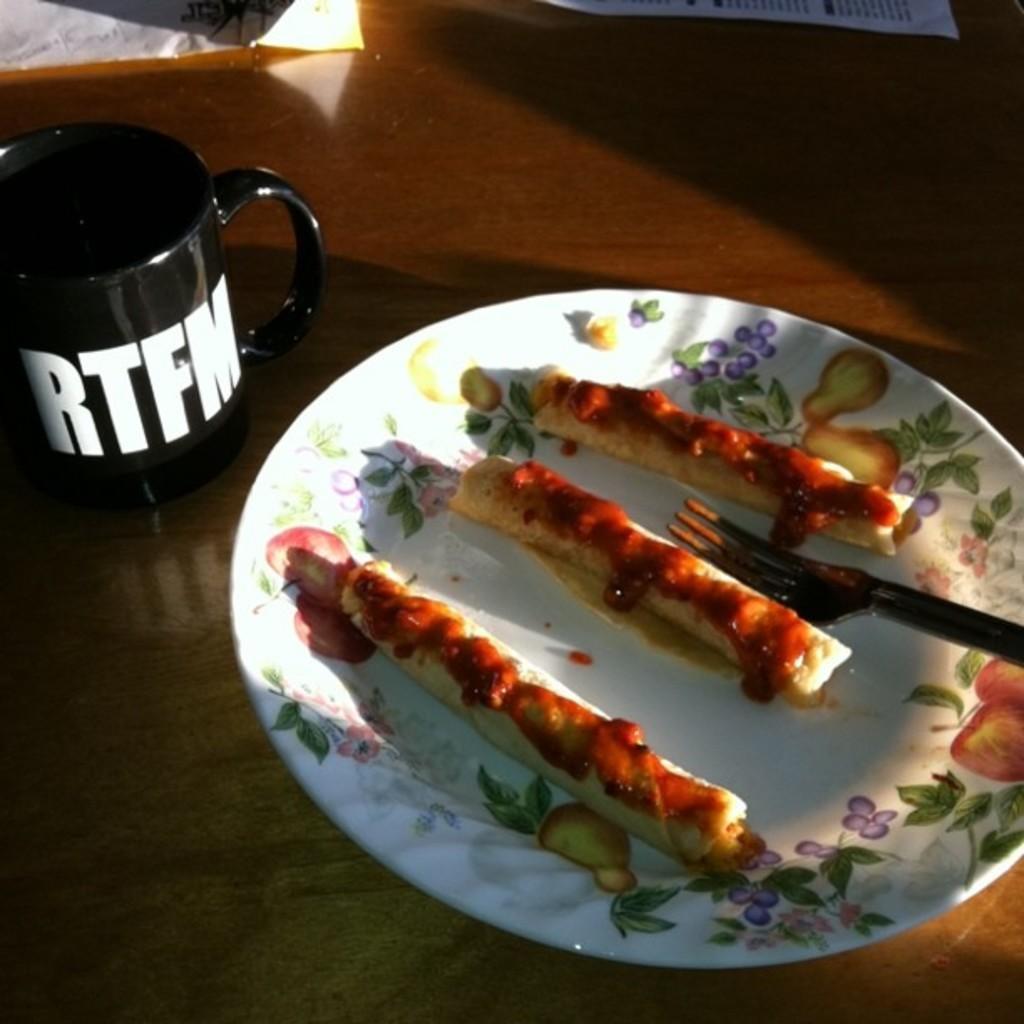Can you describe this image briefly? In this image there is a food item kept in a white color plate on the right side of this image and there is a floor in the background. There is a black color cup is on the left side of this image, and there are some white color papers kept on the floor on the top of this image. 